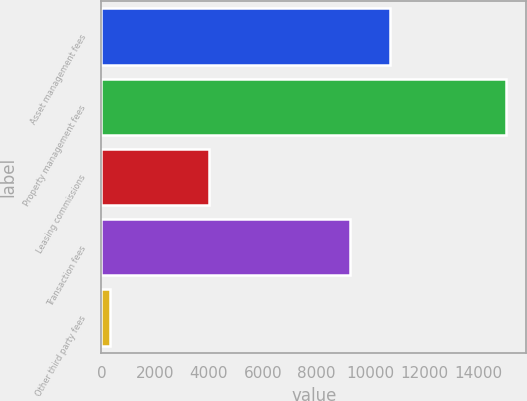Convert chart. <chart><loc_0><loc_0><loc_500><loc_500><bar_chart><fcel>Asset management fees<fcel>Property management fees<fcel>Leasing commissions<fcel>Transaction fees<fcel>Other third party fees<nl><fcel>10719.5<fcel>15031<fcel>4012<fcel>9249<fcel>326<nl></chart> 